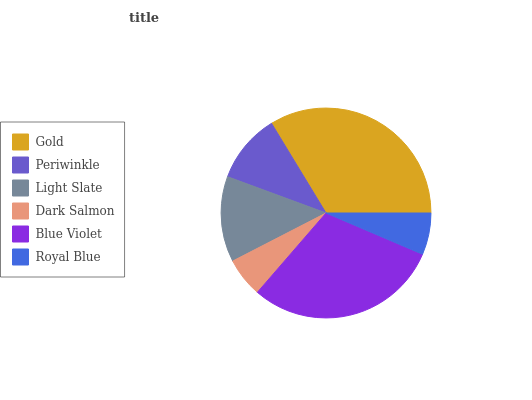Is Dark Salmon the minimum?
Answer yes or no. Yes. Is Gold the maximum?
Answer yes or no. Yes. Is Periwinkle the minimum?
Answer yes or no. No. Is Periwinkle the maximum?
Answer yes or no. No. Is Gold greater than Periwinkle?
Answer yes or no. Yes. Is Periwinkle less than Gold?
Answer yes or no. Yes. Is Periwinkle greater than Gold?
Answer yes or no. No. Is Gold less than Periwinkle?
Answer yes or no. No. Is Light Slate the high median?
Answer yes or no. Yes. Is Periwinkle the low median?
Answer yes or no. Yes. Is Periwinkle the high median?
Answer yes or no. No. Is Gold the low median?
Answer yes or no. No. 